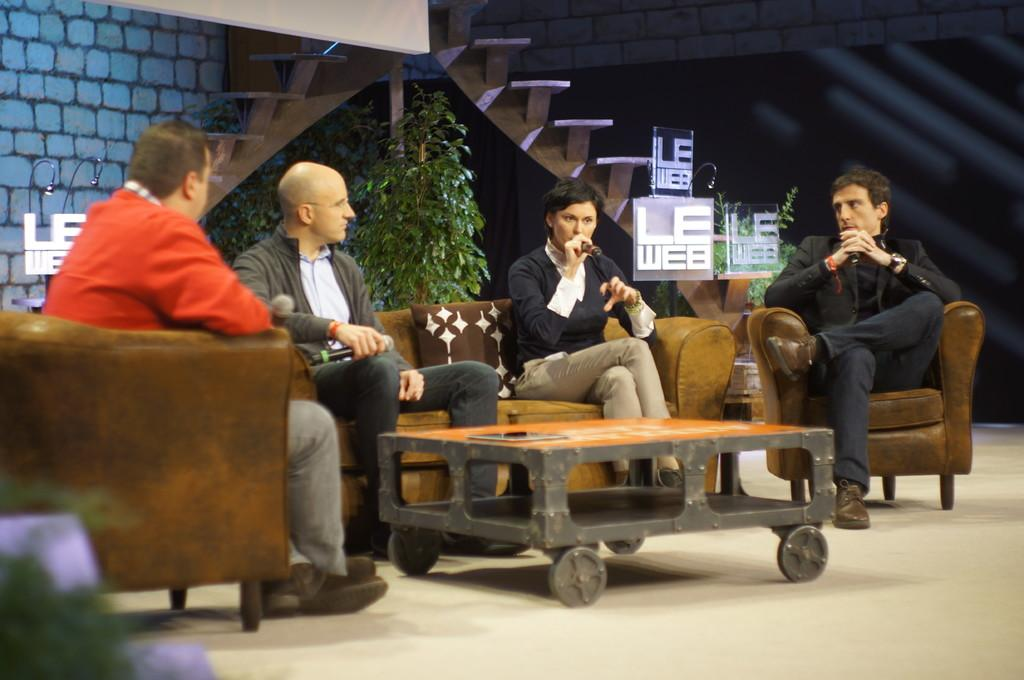How many people are sitting on the sofa in the image? There are four persons sitting on the sofa in the image. What other furniture can be seen in the image? There is a table in the image. What type of vegetation is present in the image? There is a plant in the image. What part of the room is visible in the image? The floor is visible in the image. What is visible in the background of the image? There is a wall in the background of the image. What type of creature is crawling on the wall in the image? There is no creature visible on the wall in the image. What vase is placed on the table in the image? There is no vase present on the table in the image. 